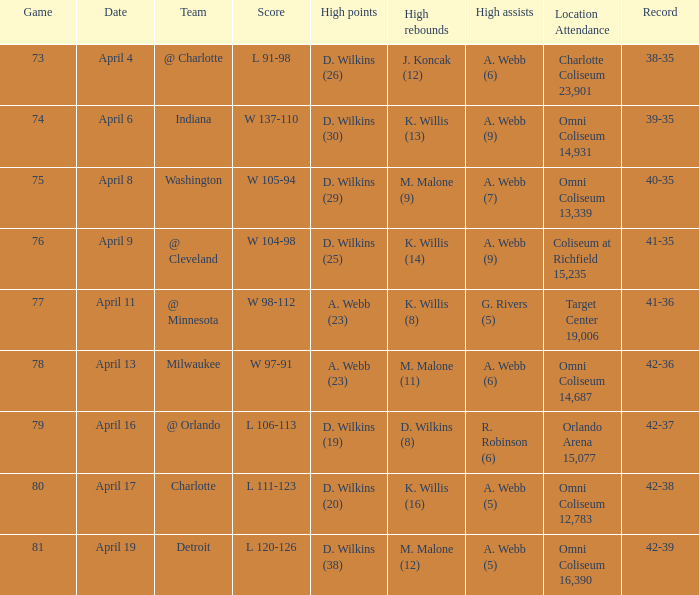Who had the most assists when playing against indiana? A. Webb (9). 